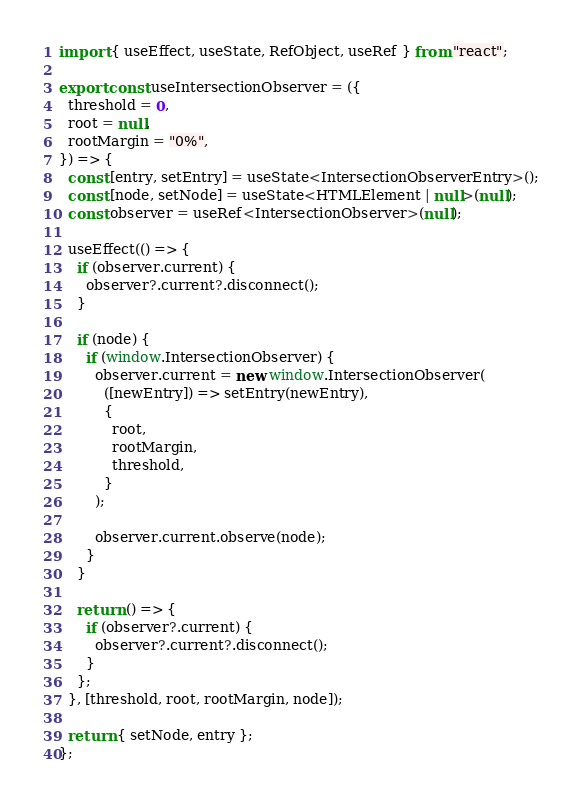<code> <loc_0><loc_0><loc_500><loc_500><_TypeScript_>import { useEffect, useState, RefObject, useRef } from "react";

export const useIntersectionObserver = ({
  threshold = 0,
  root = null,
  rootMargin = "0%",
}) => {
  const [entry, setEntry] = useState<IntersectionObserverEntry>();
  const [node, setNode] = useState<HTMLElement | null>(null);
  const observer = useRef<IntersectionObserver>(null);

  useEffect(() => {
    if (observer.current) {
      observer?.current?.disconnect();
    }

    if (node) {
      if (window.IntersectionObserver) {
        observer.current = new window.IntersectionObserver(
          ([newEntry]) => setEntry(newEntry),
          {
            root,
            rootMargin,
            threshold,
          }
        );

        observer.current.observe(node);
      }
    }

    return () => {
      if (observer?.current) {
        observer?.current?.disconnect();
      }
    };
  }, [threshold, root, rootMargin, node]);

  return { setNode, entry };
};
</code> 